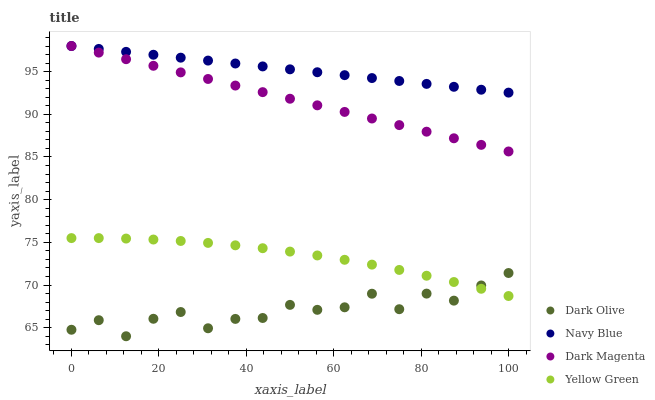Does Dark Olive have the minimum area under the curve?
Answer yes or no. Yes. Does Navy Blue have the maximum area under the curve?
Answer yes or no. Yes. Does Dark Magenta have the minimum area under the curve?
Answer yes or no. No. Does Dark Magenta have the maximum area under the curve?
Answer yes or no. No. Is Dark Magenta the smoothest?
Answer yes or no. Yes. Is Dark Olive the roughest?
Answer yes or no. Yes. Is Dark Olive the smoothest?
Answer yes or no. No. Is Dark Magenta the roughest?
Answer yes or no. No. Does Dark Olive have the lowest value?
Answer yes or no. Yes. Does Dark Magenta have the lowest value?
Answer yes or no. No. Does Dark Magenta have the highest value?
Answer yes or no. Yes. Does Dark Olive have the highest value?
Answer yes or no. No. Is Yellow Green less than Dark Magenta?
Answer yes or no. Yes. Is Navy Blue greater than Yellow Green?
Answer yes or no. Yes. Does Dark Magenta intersect Navy Blue?
Answer yes or no. Yes. Is Dark Magenta less than Navy Blue?
Answer yes or no. No. Is Dark Magenta greater than Navy Blue?
Answer yes or no. No. Does Yellow Green intersect Dark Magenta?
Answer yes or no. No. 